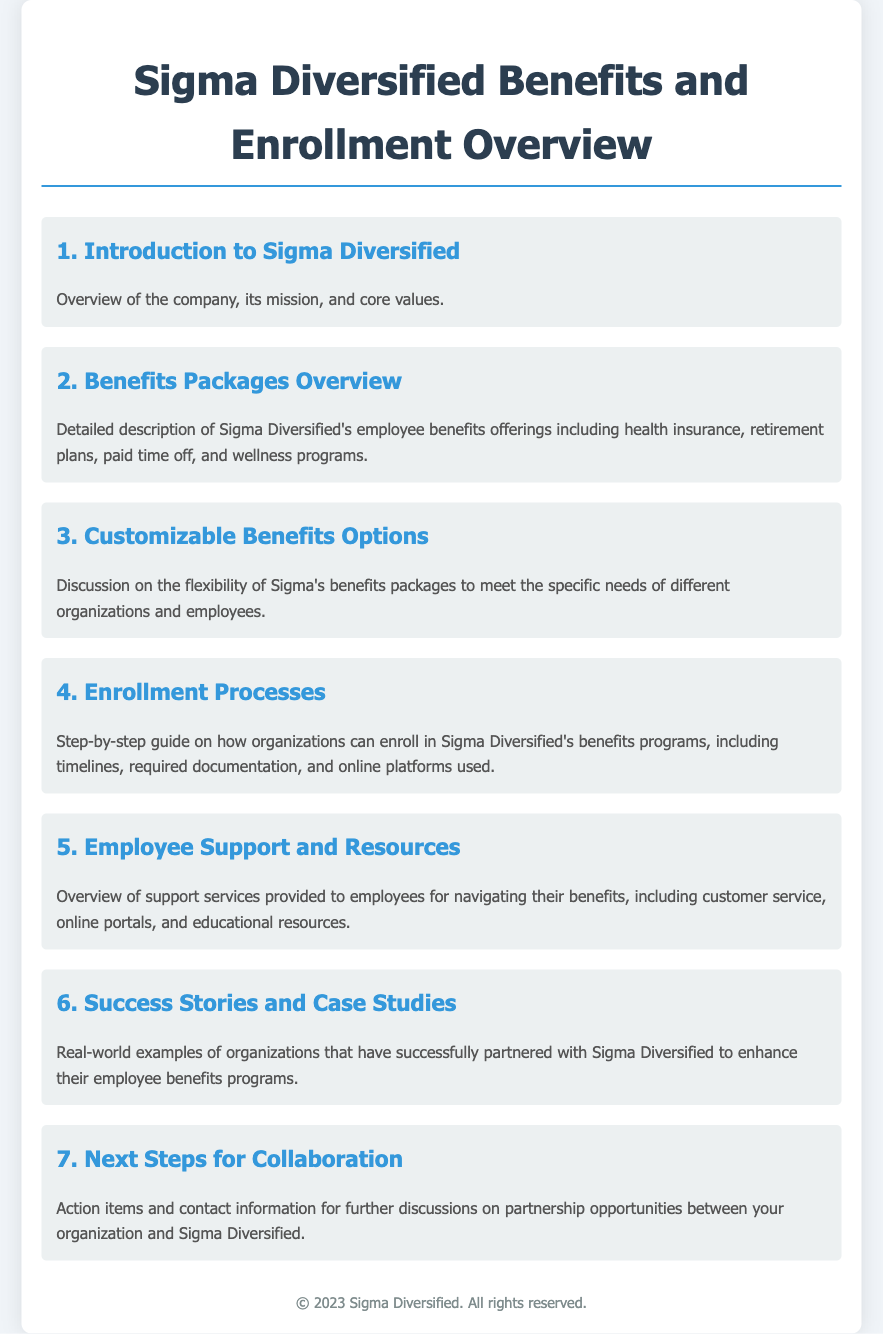what is the title of the document? The title is stated at the top of the document, which summarizes the main focus.
Answer: Sigma Diversified Benefits and Enrollment Overview how many agenda items are listed? The document enumerates each agenda item, making it easy to count.
Answer: 7 what is included in the benefits packages overview? The benefits packages overview describes various aspects of employee benefits offerings.
Answer: health insurance, retirement plans, paid time off, and wellness programs what does the introduction to Sigma Diversified cover? The introduction item encapsulates key elements about the company.
Answer: Overview of the company, its mission, and core values what is mentioned in the next steps for collaboration? The next steps item should include actionable follow-up details for a potential partnership.
Answer: Action items and contact information for further discussions how does Sigma Diversified support employees? Employee support is detailed in one of the agenda items, indicating available resources.
Answer: customer service, online portals, and educational resources what is the significance of the success stories item? This item highlights practical examples that demonstrate effectiveness.
Answer: Real-world examples of organizations that have successfully partnered with Sigma Diversified 